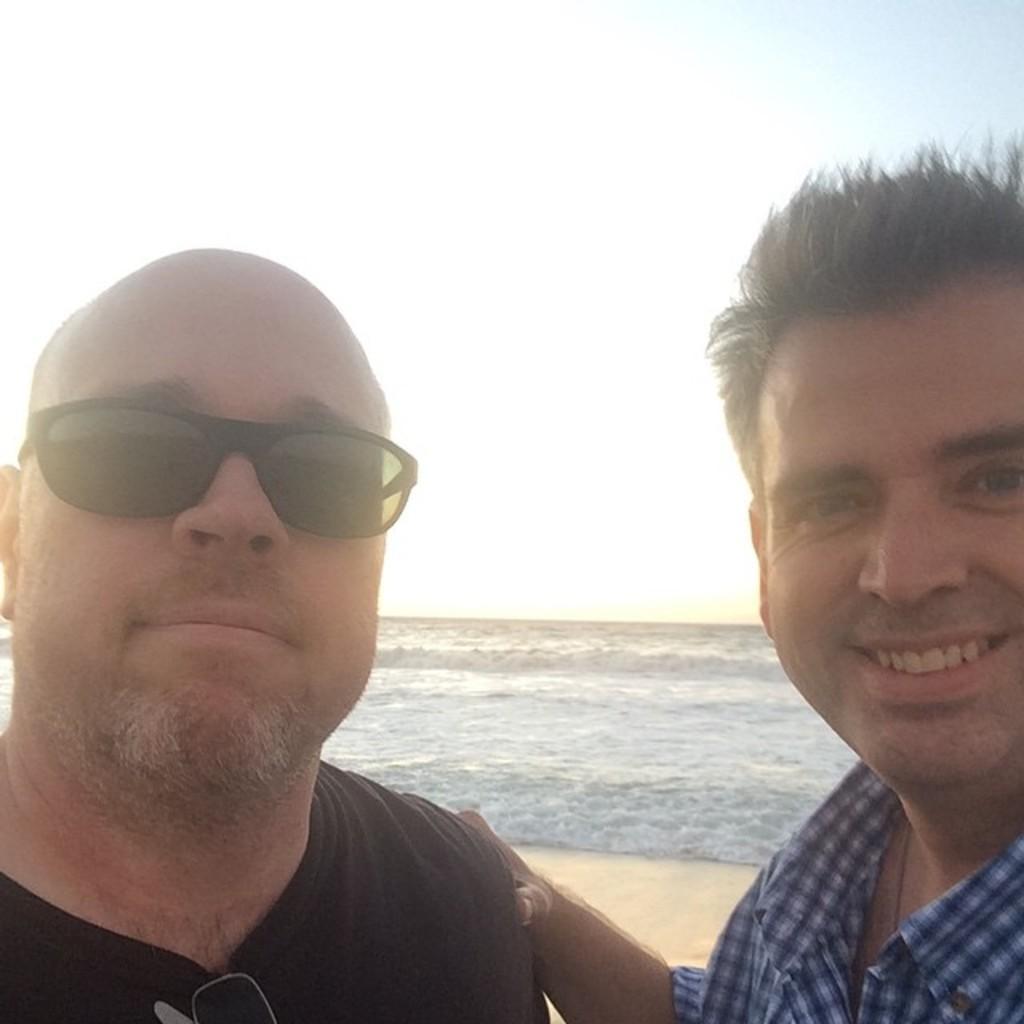Please provide a concise description of this image. In this image there is a man, he is wearing blue T-shirt and black spectacles and another man wearing blue and white color shirt, in the background there is a beach and a sky. 